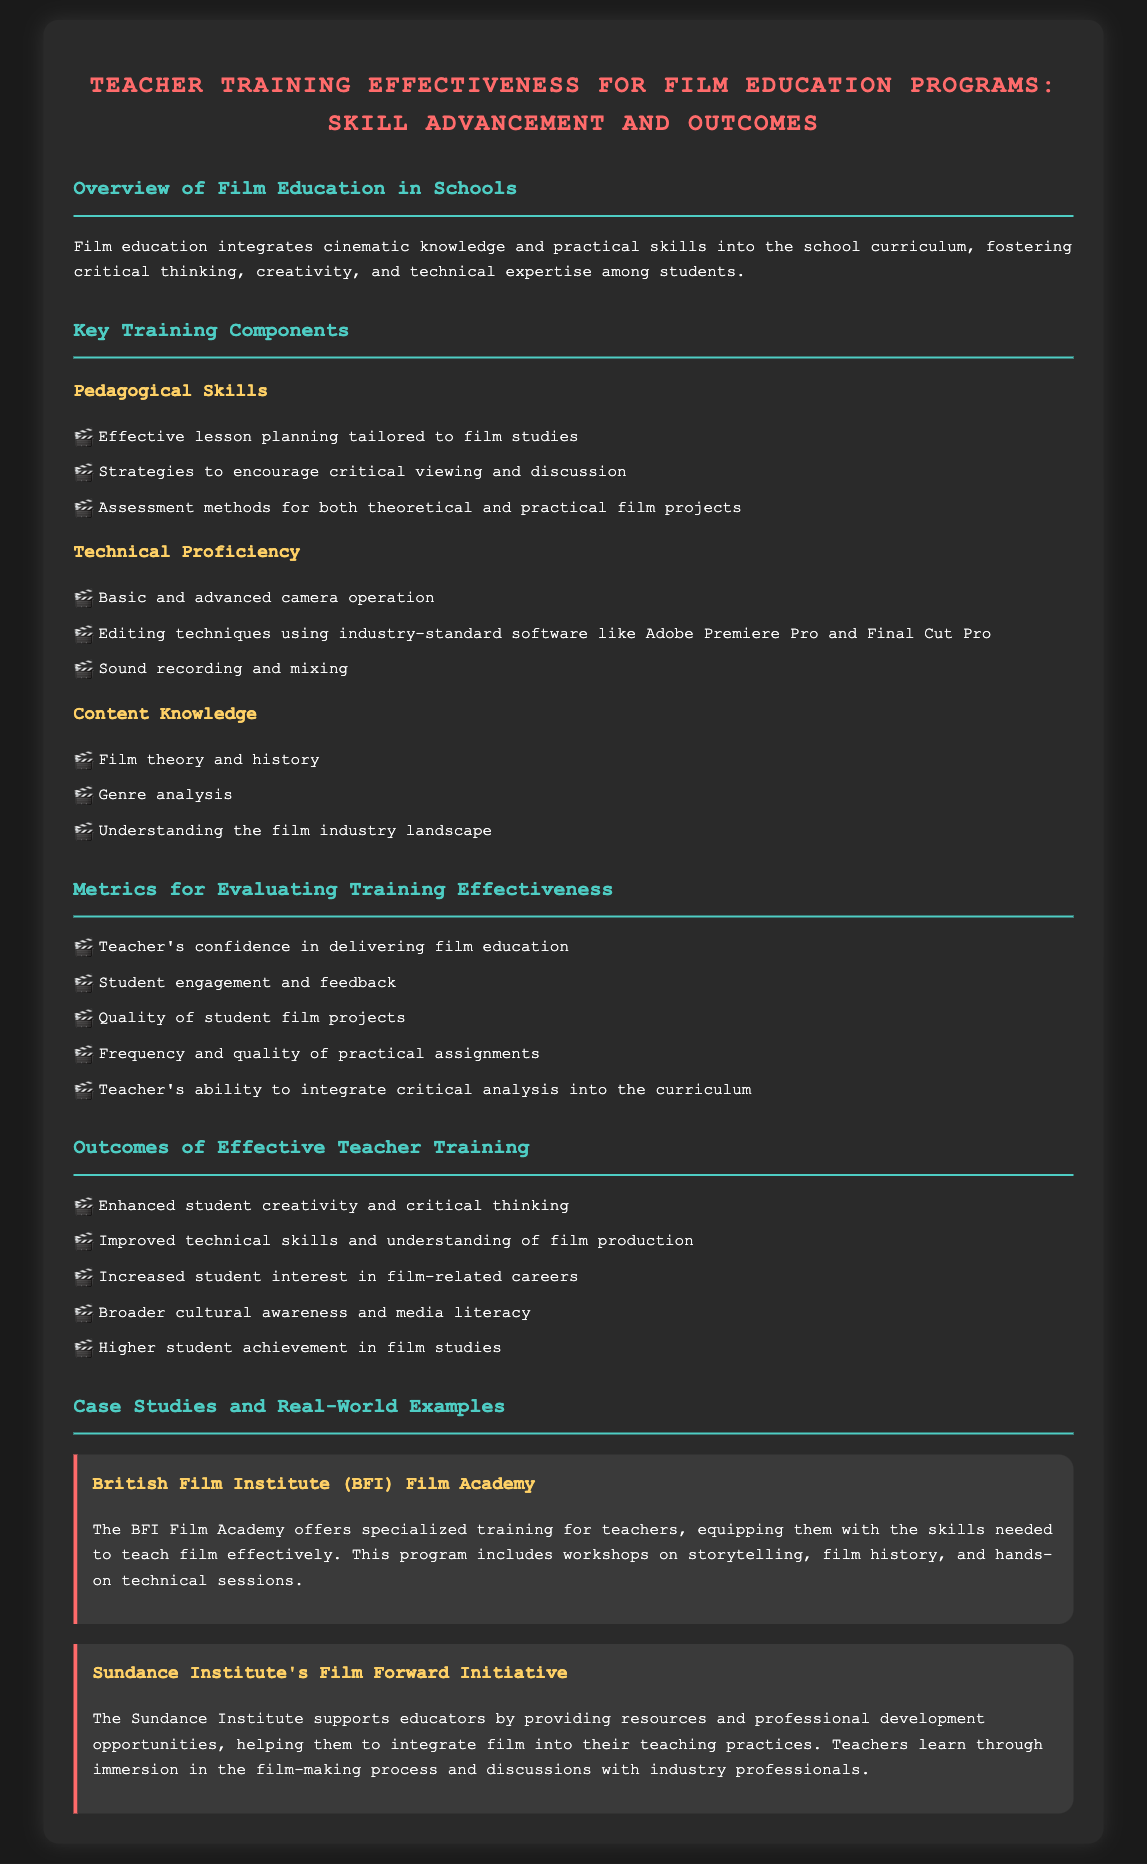What is the primary focus of film education in schools? The primary focus is to integrate cinematic knowledge and practical skills into the school curriculum.
Answer: integrating cinematic knowledge and practical skills What are two key components of teacher training in film education? The document lists pedagogical skills and technical proficiency as key components.
Answer: pedagogical skills and technical proficiency Which software is mentioned for editing techniques? The document specifies Adobe Premiere Pro and Final Cut Pro as industry-standard software for editing.
Answer: Adobe Premiere Pro and Final Cut Pro What is one metric for evaluating training effectiveness? The metrics include teacher's confidence in delivering film education.
Answer: teacher's confidence in delivering film education What outcome is linked to enhanced student creativity? The document states that enhanced student creativity leads to improved technical skills and understanding of film production.
Answer: improved technical skills and understanding of film production Who provides specialized training for teachers mentioned in the case studies? The British Film Institute (BFI) is noted for offering specialized training for teachers.
Answer: British Film Institute (BFI) What initiative does the Sundance Institute offer for educators? The Sundance Institute's initiative is named Film Forward.
Answer: Film Forward How many areas are listed under keys to effective teacher training components? The document lists three areas: pedagogical skills, technical proficiency, and content knowledge.
Answer: three What is one benefit of effective teacher training according to the outcomes? One benefit is increased student interest in film-related careers.
Answer: increased student interest in film-related careers 